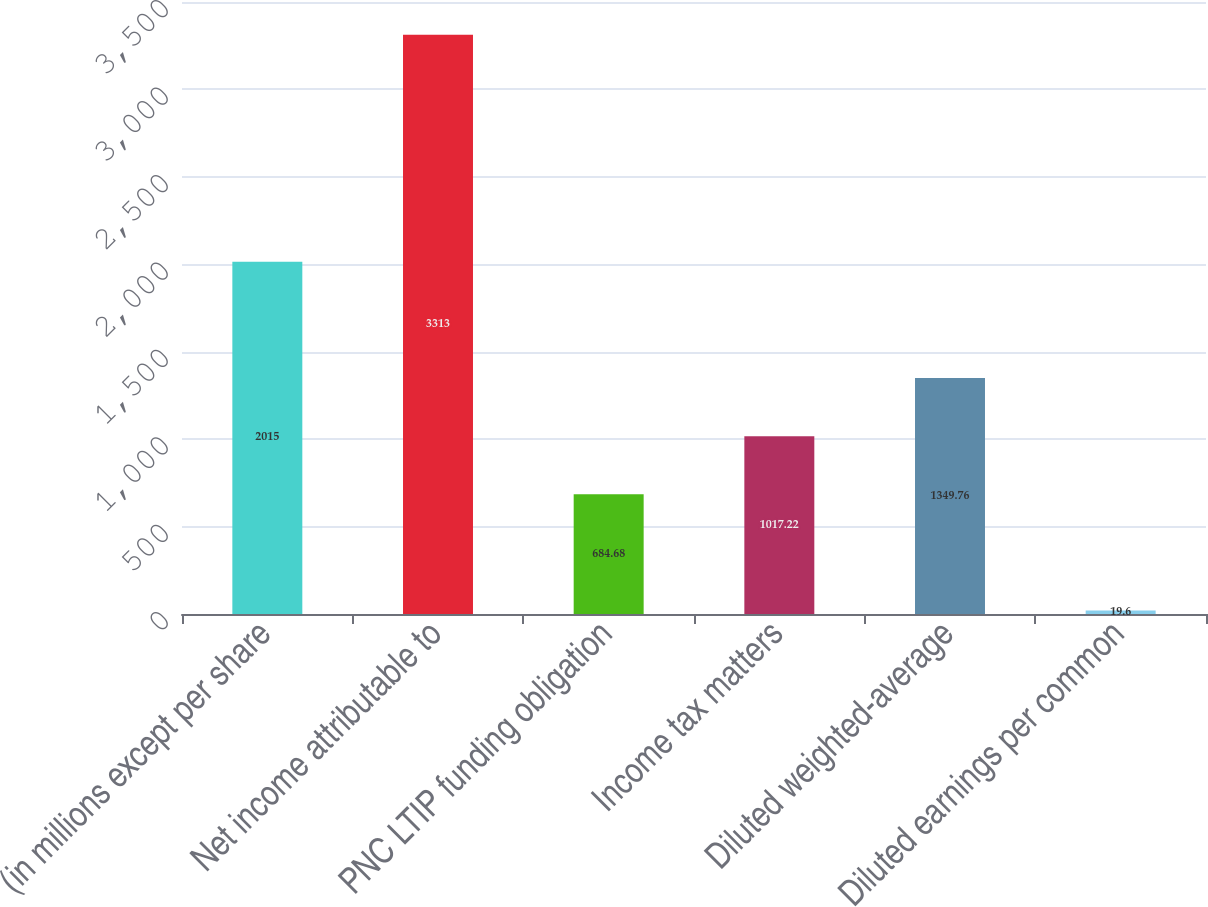<chart> <loc_0><loc_0><loc_500><loc_500><bar_chart><fcel>(in millions except per share<fcel>Net income attributable to<fcel>PNC LTIP funding obligation<fcel>Income tax matters<fcel>Diluted weighted-average<fcel>Diluted earnings per common<nl><fcel>2015<fcel>3313<fcel>684.68<fcel>1017.22<fcel>1349.76<fcel>19.6<nl></chart> 